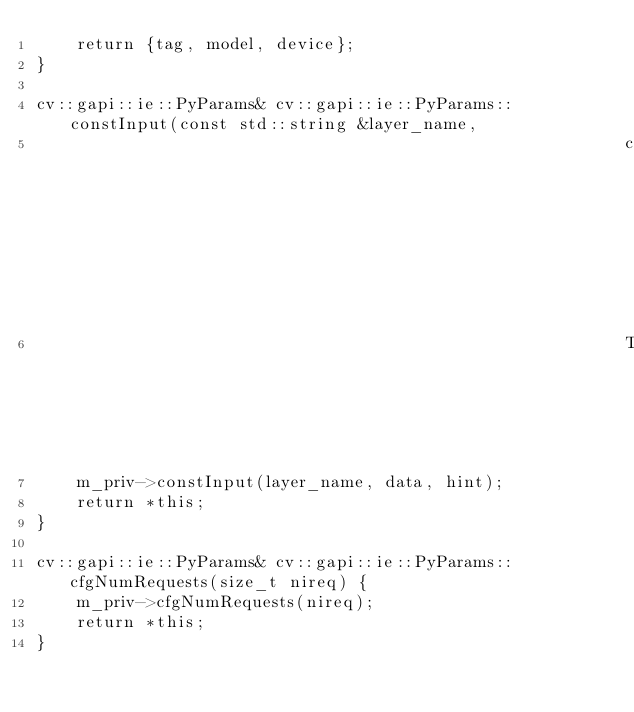<code> <loc_0><loc_0><loc_500><loc_500><_C++_>    return {tag, model, device};
}

cv::gapi::ie::PyParams& cv::gapi::ie::PyParams::constInput(const std::string &layer_name,
                                                           const cv::Mat &data,
                                                           TraitAs hint) {
    m_priv->constInput(layer_name, data, hint);
    return *this;
}

cv::gapi::ie::PyParams& cv::gapi::ie::PyParams::cfgNumRequests(size_t nireq) {
    m_priv->cfgNumRequests(nireq);
    return *this;
}
</code> 